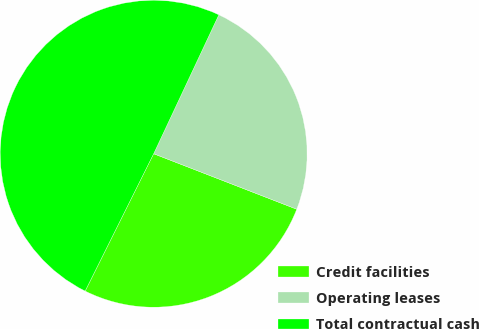Convert chart. <chart><loc_0><loc_0><loc_500><loc_500><pie_chart><fcel>Credit facilities<fcel>Operating leases<fcel>Total contractual cash<nl><fcel>26.48%<fcel>23.91%<fcel>49.62%<nl></chart> 